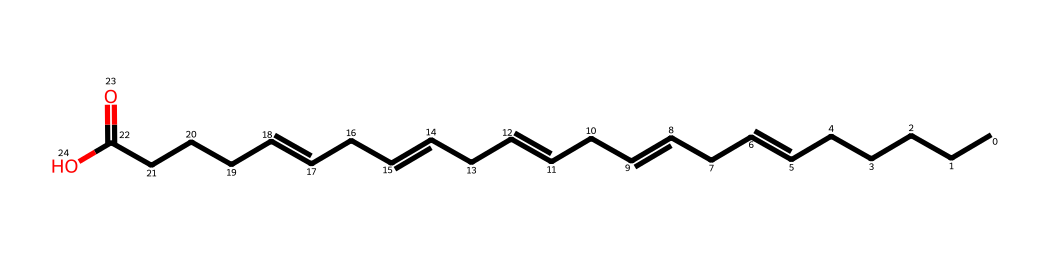What is the general structure type of this molecule? The molecule presented is a fatty acid, characterized by a long hydrocarbon chain and a carboxyl group at one end. The SMILES representation shows a series of carbon (C) atoms connected in a linear fashion, which is typical of fatty acids.
Answer: fatty acid How many carbon atoms are in the molecule? By interpreting the SMILES representation, count the carbon (C) symbols present. The structure indicates that there are 21 carbon atoms in total, including the one in the carboxyl group.
Answer: 21 What type of unsaturation is present in the molecule? The SMILES shows multiple '=' signs, which represent double bonds. This indicates it has several points of unsaturation, specifically two double bonds in this fatty acid chain.
Answer: polyunsaturated Which component of the molecule determines its classification as an omega-3 fatty acid? The omega-3 designation refers specifically to the presence of a double bond at the third carbon from the methyl end of the fatty acid chain. The structure shows a double bond located at the correct position to classify it as omega-3.
Answer: double bond What is the significance of having multiple double bonds in this fatty acid? Multiple double bonds in fatty acids lead to increased fluidity and lower melting points, making them healthier choices for cardiovascular health as they help maintain cellular membrane flexibility. This is an important feature of omega-3 fatty acids.
Answer: fluidity How does the length of the carbon chain affect the physical properties of this fatty acid? A longer carbon chain typically results in higher melting points and a more viscous liquid state. The lengthy hydrocarbon chain in this molecule contributes to its lipid nature, affecting how it behaves in biological systems.
Answer: higher melting point 